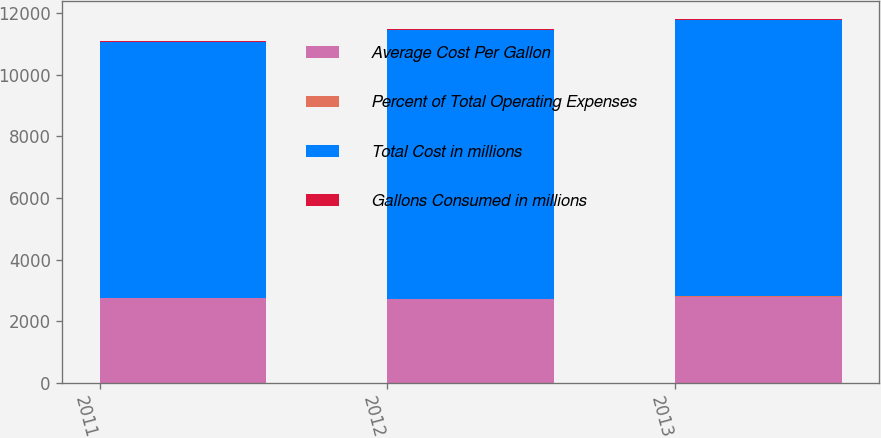Convert chart to OTSL. <chart><loc_0><loc_0><loc_500><loc_500><stacked_bar_chart><ecel><fcel>2011<fcel>2012<fcel>2013<nl><fcel>Average Cost Per Gallon<fcel>2756<fcel>2723<fcel>2806<nl><fcel>Percent of Total Operating Expenses<fcel>3.01<fcel>3.2<fcel>3.09<nl><fcel>Total Cost in millions<fcel>8304<fcel>8717<fcel>8959<nl><fcel>Gallons Consumed in millions<fcel>33.2<fcel>35.3<fcel>35.3<nl></chart> 